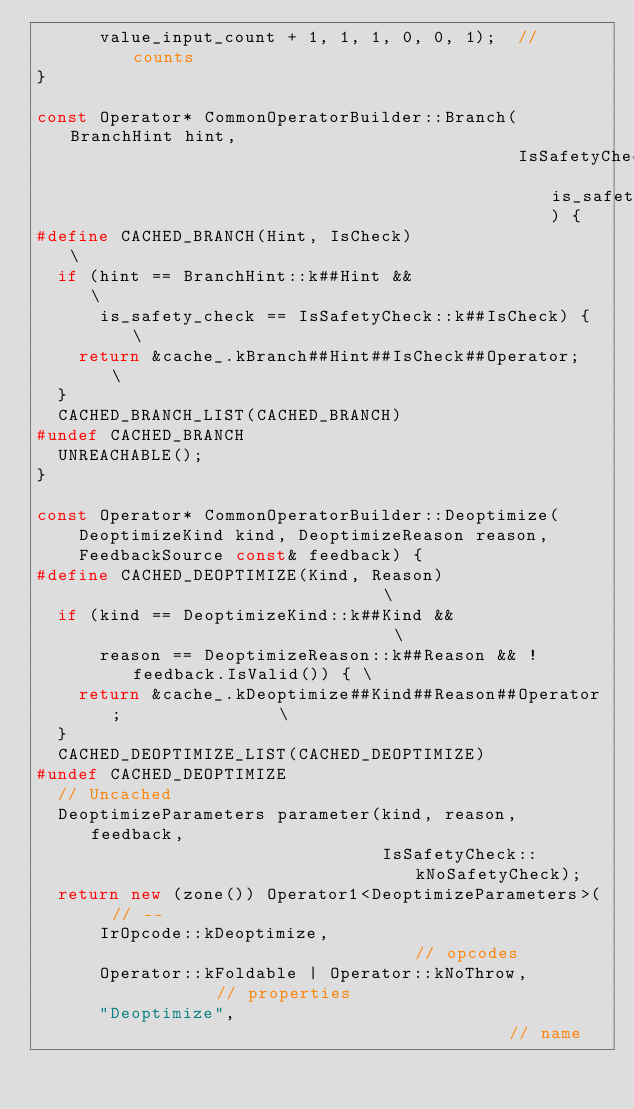<code> <loc_0><loc_0><loc_500><loc_500><_C++_>      value_input_count + 1, 1, 1, 0, 0, 1);  // counts
}

const Operator* CommonOperatorBuilder::Branch(BranchHint hint,
                                              IsSafetyCheck is_safety_check) {
#define CACHED_BRANCH(Hint, IsCheck)                  \
  if (hint == BranchHint::k##Hint &&                  \
      is_safety_check == IsSafetyCheck::k##IsCheck) { \
    return &cache_.kBranch##Hint##IsCheck##Operator;  \
  }
  CACHED_BRANCH_LIST(CACHED_BRANCH)
#undef CACHED_BRANCH
  UNREACHABLE();
}

const Operator* CommonOperatorBuilder::Deoptimize(
    DeoptimizeKind kind, DeoptimizeReason reason,
    FeedbackSource const& feedback) {
#define CACHED_DEOPTIMIZE(Kind, Reason)                               \
  if (kind == DeoptimizeKind::k##Kind &&                              \
      reason == DeoptimizeReason::k##Reason && !feedback.IsValid()) { \
    return &cache_.kDeoptimize##Kind##Reason##Operator;               \
  }
  CACHED_DEOPTIMIZE_LIST(CACHED_DEOPTIMIZE)
#undef CACHED_DEOPTIMIZE
  // Uncached
  DeoptimizeParameters parameter(kind, reason, feedback,
                                 IsSafetyCheck::kNoSafetyCheck);
  return new (zone()) Operator1<DeoptimizeParameters>(  // --
      IrOpcode::kDeoptimize,                            // opcodes
      Operator::kFoldable | Operator::kNoThrow,         // properties
      "Deoptimize",                                     // name</code> 